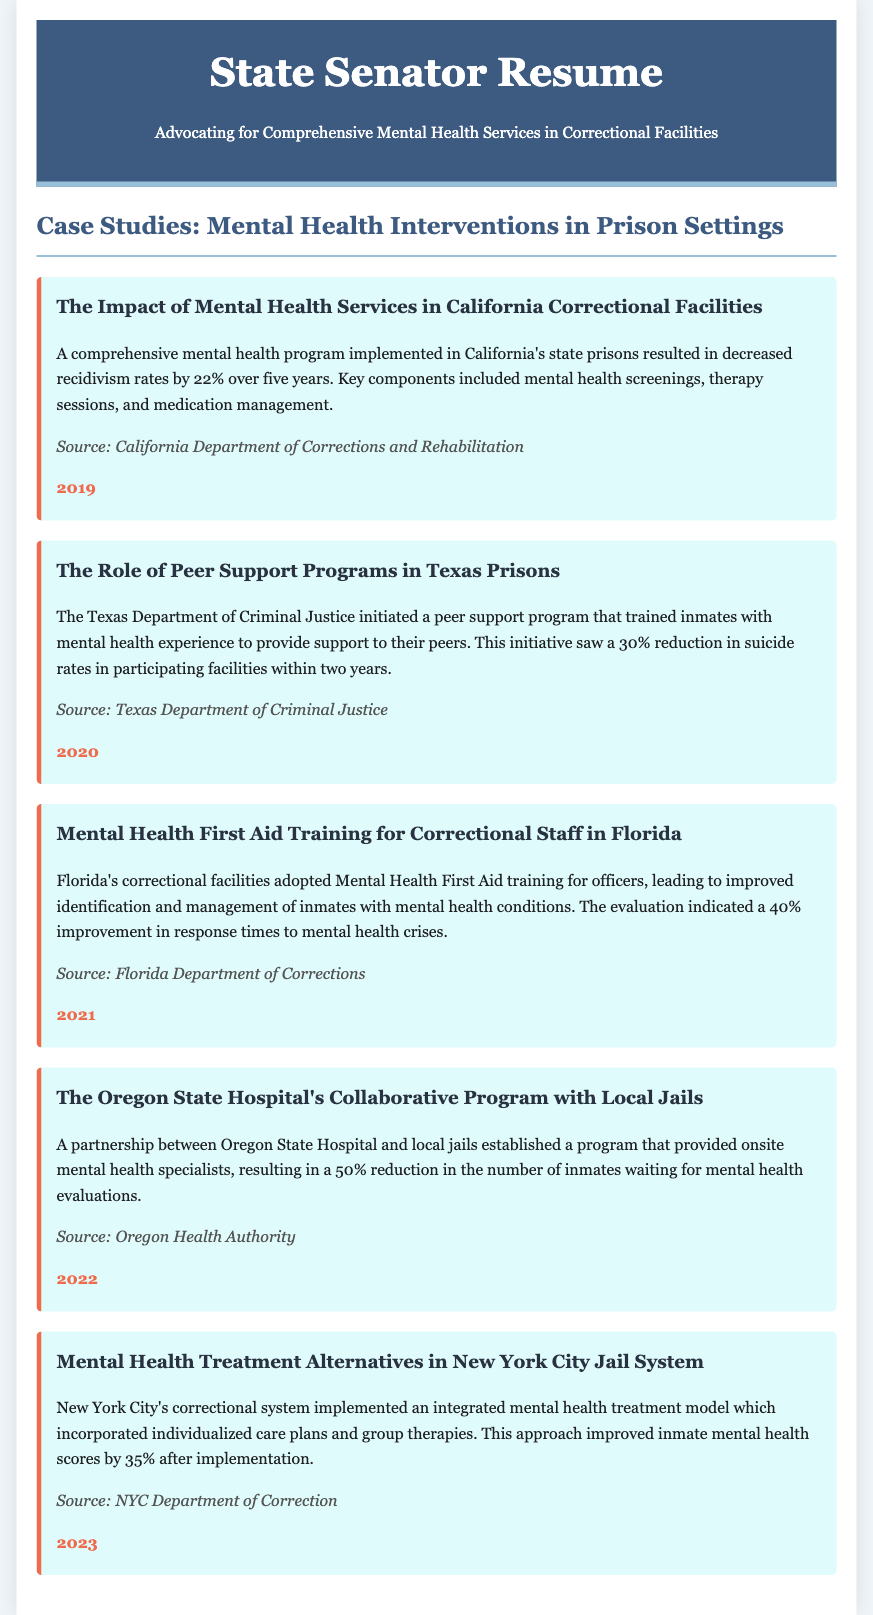What was the percentage decrease in recidivism rates in California? The document states that there was a 22% decrease in recidivism rates over five years in California's state prisons due to the comprehensive mental health program.
Answer: 22% What year did Texas initiate the peer support program? According to the document, the peer support program was initiated in Texas prisons in 2020.
Answer: 2020 What improvement in response times was reported after Mental Health First Aid training was implemented in Florida? The document mentions a 40% improvement in response times to mental health crises after the training was adopted in Florida's correctional facilities.
Answer: 40% What was the reduction in the number of inmates waiting for mental health evaluations in Oregon? The partnership in Oregon resulted in a 50% reduction in the number of inmates waiting for mental health evaluations.
Answer: 50% What mental health model did New York City implement in its correctional system? The document refers to an integrated mental health treatment model that incorporated individualized care plans and group therapies in New York City.
Answer: Integrated mental health treatment model What source provided information on the California correctional facilities program? The source listed for California's mental health program is the California Department of Corrections and Rehabilitation.
Answer: California Department of Corrections and Rehabilitation What was the main goal of the peer support program in Texas? The primary goal was to train inmates with mental health experience to provide support to their peers in Texas prisons.
Answer: Support to their peers What specific training did Florida correctional staff receive? Florida correctional staff received Mental Health First Aid training.
Answer: Mental Health First Aid training What was the improvement in inmate mental health scores reported after the NYC intervention? After the implementation of the intervention in New York City, there was a 35% improvement in inmate mental health scores.
Answer: 35% 